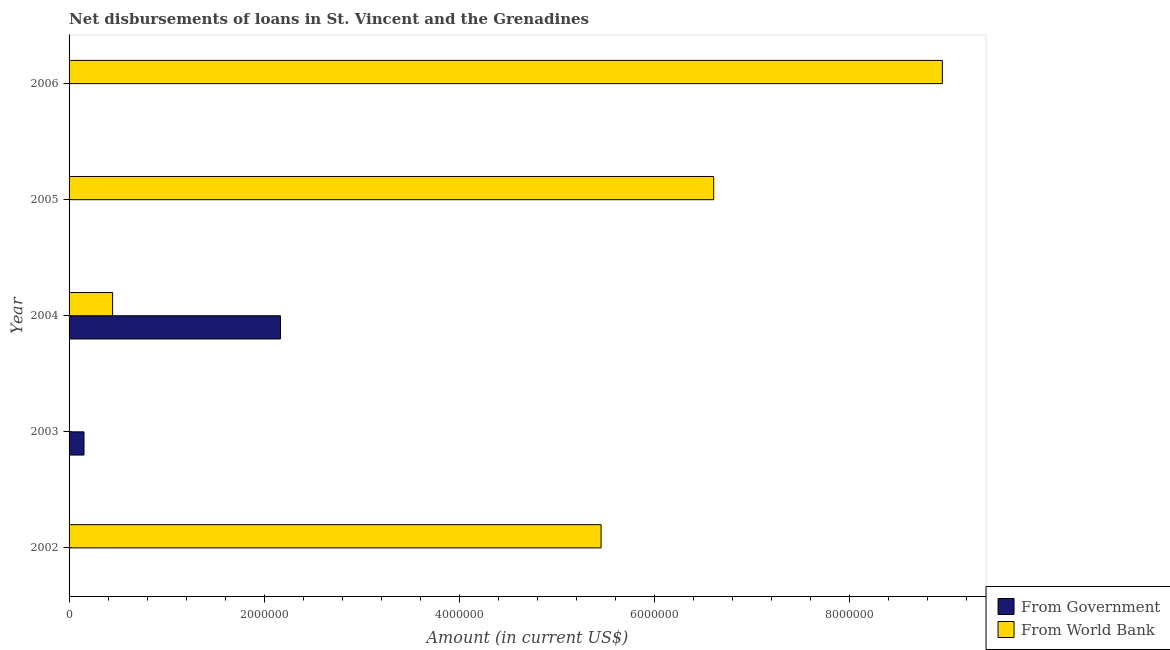Are the number of bars on each tick of the Y-axis equal?
Your response must be concise. No. How many bars are there on the 5th tick from the top?
Your answer should be very brief. 1. What is the label of the 5th group of bars from the top?
Offer a very short reply. 2002. In how many cases, is the number of bars for a given year not equal to the number of legend labels?
Keep it short and to the point. 4. Across all years, what is the maximum net disbursements of loan from government?
Give a very brief answer. 2.17e+06. What is the total net disbursements of loan from world bank in the graph?
Give a very brief answer. 2.14e+07. What is the difference between the net disbursements of loan from government in 2003 and that in 2004?
Your answer should be compact. -2.01e+06. What is the difference between the net disbursements of loan from world bank in 2002 and the net disbursements of loan from government in 2003?
Provide a short and direct response. 5.30e+06. What is the average net disbursements of loan from world bank per year?
Offer a very short reply. 4.29e+06. In the year 2004, what is the difference between the net disbursements of loan from government and net disbursements of loan from world bank?
Offer a terse response. 1.72e+06. In how many years, is the net disbursements of loan from world bank greater than 3200000 US$?
Provide a short and direct response. 3. What is the ratio of the net disbursements of loan from government in 2003 to that in 2004?
Your answer should be compact. 0.07. Is the net disbursements of loan from world bank in 2002 less than that in 2005?
Your response must be concise. Yes. What is the difference between the highest and the second highest net disbursements of loan from world bank?
Give a very brief answer. 2.34e+06. What is the difference between the highest and the lowest net disbursements of loan from government?
Provide a short and direct response. 2.17e+06. How many bars are there?
Give a very brief answer. 6. How many years are there in the graph?
Ensure brevity in your answer.  5. Are the values on the major ticks of X-axis written in scientific E-notation?
Make the answer very short. No. Does the graph contain grids?
Keep it short and to the point. No. Where does the legend appear in the graph?
Your answer should be compact. Bottom right. How many legend labels are there?
Keep it short and to the point. 2. How are the legend labels stacked?
Keep it short and to the point. Vertical. What is the title of the graph?
Ensure brevity in your answer.  Net disbursements of loans in St. Vincent and the Grenadines. Does "Manufacturing industries and construction" appear as one of the legend labels in the graph?
Provide a succinct answer. No. What is the Amount (in current US$) in From Government in 2002?
Your answer should be compact. 0. What is the Amount (in current US$) of From World Bank in 2002?
Provide a succinct answer. 5.45e+06. What is the Amount (in current US$) of From Government in 2003?
Make the answer very short. 1.53e+05. What is the Amount (in current US$) in From World Bank in 2003?
Provide a succinct answer. 0. What is the Amount (in current US$) in From Government in 2004?
Ensure brevity in your answer.  2.17e+06. What is the Amount (in current US$) in From World Bank in 2004?
Your answer should be very brief. 4.46e+05. What is the Amount (in current US$) in From Government in 2005?
Make the answer very short. 0. What is the Amount (in current US$) in From World Bank in 2005?
Your answer should be very brief. 6.60e+06. What is the Amount (in current US$) of From World Bank in 2006?
Offer a terse response. 8.95e+06. Across all years, what is the maximum Amount (in current US$) in From Government?
Make the answer very short. 2.17e+06. Across all years, what is the maximum Amount (in current US$) in From World Bank?
Offer a very short reply. 8.95e+06. Across all years, what is the minimum Amount (in current US$) in From World Bank?
Make the answer very short. 0. What is the total Amount (in current US$) in From Government in the graph?
Your response must be concise. 2.32e+06. What is the total Amount (in current US$) in From World Bank in the graph?
Keep it short and to the point. 2.14e+07. What is the difference between the Amount (in current US$) in From World Bank in 2002 and that in 2004?
Your answer should be very brief. 5.00e+06. What is the difference between the Amount (in current US$) of From World Bank in 2002 and that in 2005?
Keep it short and to the point. -1.15e+06. What is the difference between the Amount (in current US$) of From World Bank in 2002 and that in 2006?
Provide a succinct answer. -3.50e+06. What is the difference between the Amount (in current US$) in From Government in 2003 and that in 2004?
Give a very brief answer. -2.01e+06. What is the difference between the Amount (in current US$) in From World Bank in 2004 and that in 2005?
Make the answer very short. -6.16e+06. What is the difference between the Amount (in current US$) in From World Bank in 2004 and that in 2006?
Your answer should be very brief. -8.50e+06. What is the difference between the Amount (in current US$) of From World Bank in 2005 and that in 2006?
Your response must be concise. -2.34e+06. What is the difference between the Amount (in current US$) of From Government in 2003 and the Amount (in current US$) of From World Bank in 2004?
Provide a succinct answer. -2.93e+05. What is the difference between the Amount (in current US$) in From Government in 2003 and the Amount (in current US$) in From World Bank in 2005?
Ensure brevity in your answer.  -6.45e+06. What is the difference between the Amount (in current US$) of From Government in 2003 and the Amount (in current US$) of From World Bank in 2006?
Make the answer very short. -8.80e+06. What is the difference between the Amount (in current US$) of From Government in 2004 and the Amount (in current US$) of From World Bank in 2005?
Offer a very short reply. -4.44e+06. What is the difference between the Amount (in current US$) of From Government in 2004 and the Amount (in current US$) of From World Bank in 2006?
Offer a very short reply. -6.78e+06. What is the average Amount (in current US$) in From Government per year?
Ensure brevity in your answer.  4.64e+05. What is the average Amount (in current US$) in From World Bank per year?
Provide a succinct answer. 4.29e+06. In the year 2004, what is the difference between the Amount (in current US$) of From Government and Amount (in current US$) of From World Bank?
Provide a short and direct response. 1.72e+06. What is the ratio of the Amount (in current US$) in From World Bank in 2002 to that in 2004?
Your answer should be very brief. 12.22. What is the ratio of the Amount (in current US$) of From World Bank in 2002 to that in 2005?
Offer a very short reply. 0.83. What is the ratio of the Amount (in current US$) of From World Bank in 2002 to that in 2006?
Provide a succinct answer. 0.61. What is the ratio of the Amount (in current US$) in From Government in 2003 to that in 2004?
Your response must be concise. 0.07. What is the ratio of the Amount (in current US$) of From World Bank in 2004 to that in 2005?
Make the answer very short. 0.07. What is the ratio of the Amount (in current US$) of From World Bank in 2004 to that in 2006?
Offer a very short reply. 0.05. What is the ratio of the Amount (in current US$) of From World Bank in 2005 to that in 2006?
Offer a very short reply. 0.74. What is the difference between the highest and the second highest Amount (in current US$) of From World Bank?
Provide a short and direct response. 2.34e+06. What is the difference between the highest and the lowest Amount (in current US$) in From Government?
Keep it short and to the point. 2.17e+06. What is the difference between the highest and the lowest Amount (in current US$) of From World Bank?
Keep it short and to the point. 8.95e+06. 